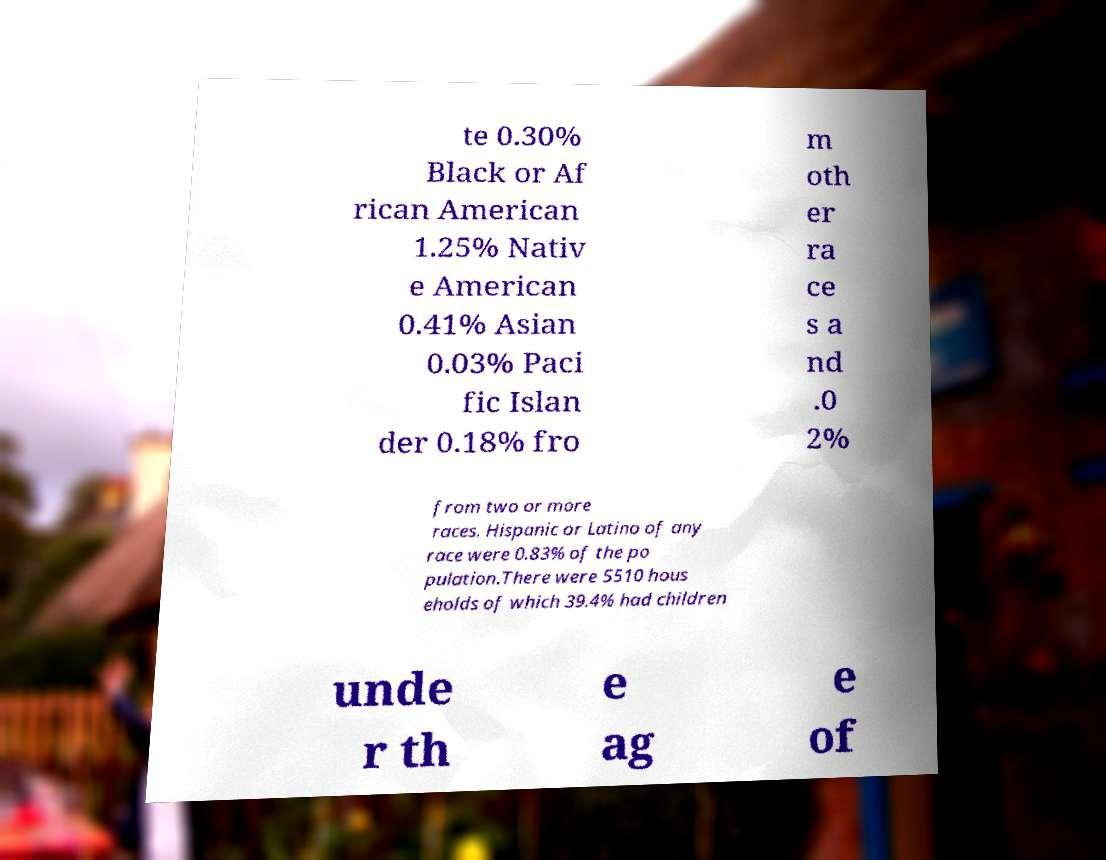Could you assist in decoding the text presented in this image and type it out clearly? te 0.30% Black or Af rican American 1.25% Nativ e American 0.41% Asian 0.03% Paci fic Islan der 0.18% fro m oth er ra ce s a nd .0 2% from two or more races. Hispanic or Latino of any race were 0.83% of the po pulation.There were 5510 hous eholds of which 39.4% had children unde r th e ag e of 